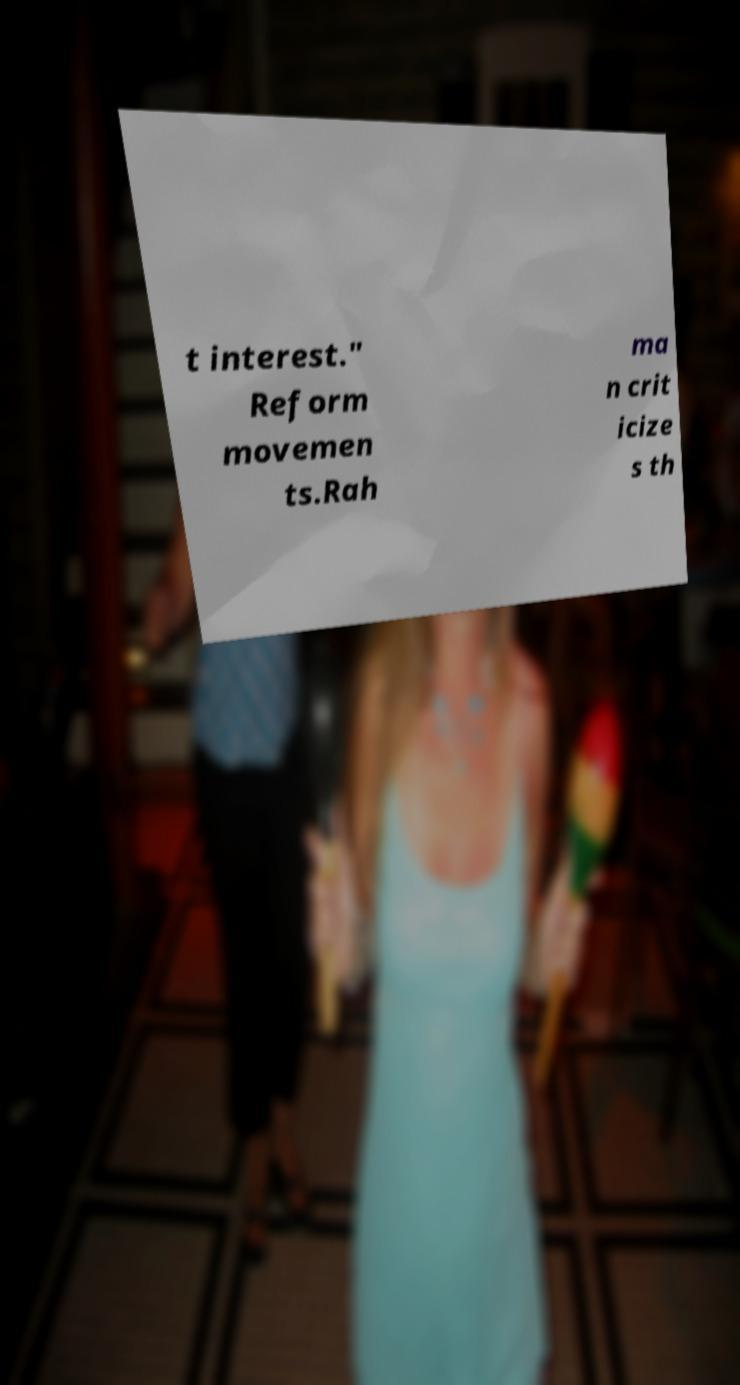I need the written content from this picture converted into text. Can you do that? t interest." Reform movemen ts.Rah ma n crit icize s th 